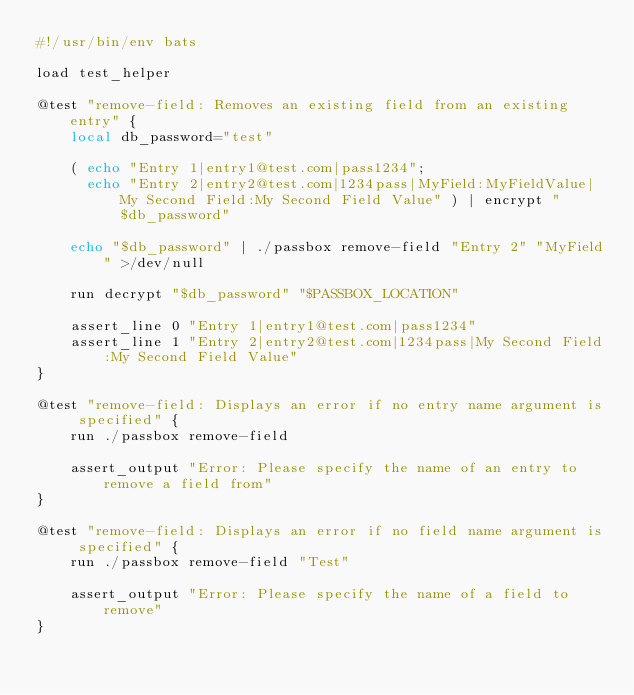<code> <loc_0><loc_0><loc_500><loc_500><_Bash_>#!/usr/bin/env bats

load test_helper

@test "remove-field: Removes an existing field from an existing entry" {
    local db_password="test"

    ( echo "Entry 1|entry1@test.com|pass1234";
      echo "Entry 2|entry2@test.com|1234pass|MyField:MyFieldValue|My Second Field:My Second Field Value" ) | encrypt "$db_password"

    echo "$db_password" | ./passbox remove-field "Entry 2" "MyField" >/dev/null

    run decrypt "$db_password" "$PASSBOX_LOCATION"

    assert_line 0 "Entry 1|entry1@test.com|pass1234"
    assert_line 1 "Entry 2|entry2@test.com|1234pass|My Second Field:My Second Field Value"
}

@test "remove-field: Displays an error if no entry name argument is specified" {
    run ./passbox remove-field

    assert_output "Error: Please specify the name of an entry to remove a field from"
}

@test "remove-field: Displays an error if no field name argument is specified" {
    run ./passbox remove-field "Test"

    assert_output "Error: Please specify the name of a field to remove"
}
</code> 